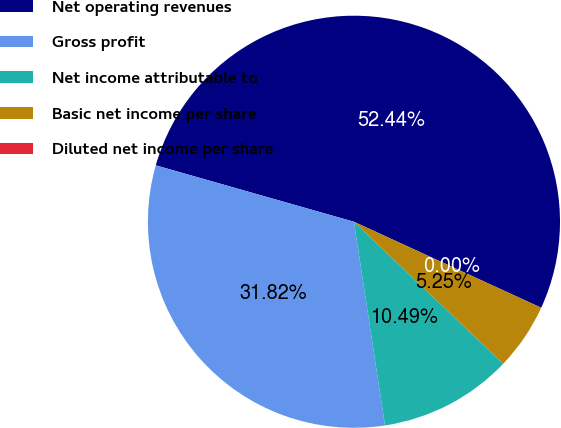Convert chart to OTSL. <chart><loc_0><loc_0><loc_500><loc_500><pie_chart><fcel>Net operating revenues<fcel>Gross profit<fcel>Net income attributable to<fcel>Basic net income per share<fcel>Diluted net income per share<nl><fcel>52.44%<fcel>31.82%<fcel>10.49%<fcel>5.25%<fcel>0.0%<nl></chart> 